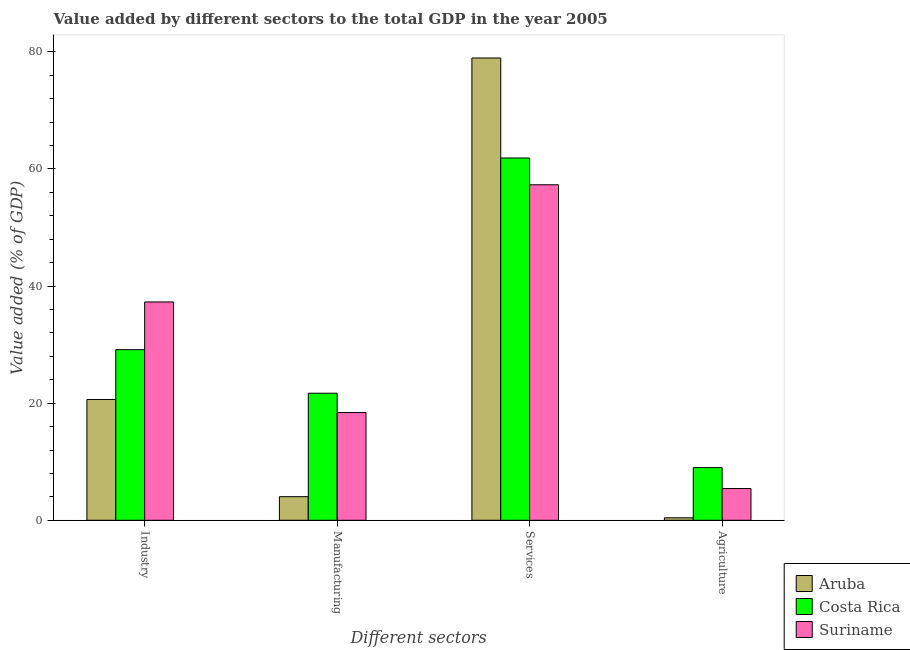How many different coloured bars are there?
Make the answer very short. 3. How many bars are there on the 2nd tick from the right?
Provide a short and direct response. 3. What is the label of the 4th group of bars from the left?
Your answer should be compact. Agriculture. What is the value added by services sector in Costa Rica?
Your response must be concise. 61.87. Across all countries, what is the maximum value added by manufacturing sector?
Make the answer very short. 21.7. Across all countries, what is the minimum value added by services sector?
Provide a succinct answer. 57.3. In which country was the value added by industrial sector minimum?
Make the answer very short. Aruba. What is the total value added by industrial sector in the graph?
Your response must be concise. 87.05. What is the difference between the value added by services sector in Suriname and that in Aruba?
Give a very brief answer. -21.65. What is the difference between the value added by industrial sector in Aruba and the value added by services sector in Costa Rica?
Your response must be concise. -41.24. What is the average value added by services sector per country?
Provide a succinct answer. 66.04. What is the difference between the value added by services sector and value added by agricultural sector in Costa Rica?
Make the answer very short. 52.88. In how many countries, is the value added by industrial sector greater than 8 %?
Your answer should be compact. 3. What is the ratio of the value added by industrial sector in Costa Rica to that in Aruba?
Offer a terse response. 1.41. Is the difference between the value added by agricultural sector in Suriname and Aruba greater than the difference between the value added by industrial sector in Suriname and Aruba?
Keep it short and to the point. No. What is the difference between the highest and the second highest value added by services sector?
Ensure brevity in your answer.  17.08. What is the difference between the highest and the lowest value added by agricultural sector?
Provide a short and direct response. 8.57. Is it the case that in every country, the sum of the value added by agricultural sector and value added by services sector is greater than the sum of value added by manufacturing sector and value added by industrial sector?
Ensure brevity in your answer.  Yes. What does the 2nd bar from the left in Services represents?
Give a very brief answer. Costa Rica. What does the 1st bar from the right in Manufacturing represents?
Your answer should be very brief. Suriname. How many bars are there?
Your answer should be compact. 12. Are all the bars in the graph horizontal?
Ensure brevity in your answer.  No. Are the values on the major ticks of Y-axis written in scientific E-notation?
Make the answer very short. No. Does the graph contain grids?
Make the answer very short. No. How many legend labels are there?
Provide a succinct answer. 3. How are the legend labels stacked?
Your answer should be very brief. Vertical. What is the title of the graph?
Keep it short and to the point. Value added by different sectors to the total GDP in the year 2005. Does "Lower middle income" appear as one of the legend labels in the graph?
Provide a short and direct response. No. What is the label or title of the X-axis?
Provide a succinct answer. Different sectors. What is the label or title of the Y-axis?
Ensure brevity in your answer.  Value added (% of GDP). What is the Value added (% of GDP) in Aruba in Industry?
Your answer should be very brief. 20.63. What is the Value added (% of GDP) of Costa Rica in Industry?
Give a very brief answer. 29.14. What is the Value added (% of GDP) in Suriname in Industry?
Your response must be concise. 37.28. What is the Value added (% of GDP) of Aruba in Manufacturing?
Make the answer very short. 4.03. What is the Value added (% of GDP) of Costa Rica in Manufacturing?
Keep it short and to the point. 21.7. What is the Value added (% of GDP) of Suriname in Manufacturing?
Offer a very short reply. 18.39. What is the Value added (% of GDP) of Aruba in Services?
Offer a terse response. 78.95. What is the Value added (% of GDP) in Costa Rica in Services?
Your answer should be compact. 61.87. What is the Value added (% of GDP) of Suriname in Services?
Your response must be concise. 57.3. What is the Value added (% of GDP) in Aruba in Agriculture?
Offer a terse response. 0.42. What is the Value added (% of GDP) of Costa Rica in Agriculture?
Your response must be concise. 8.99. What is the Value added (% of GDP) of Suriname in Agriculture?
Ensure brevity in your answer.  5.42. Across all Different sectors, what is the maximum Value added (% of GDP) of Aruba?
Ensure brevity in your answer.  78.95. Across all Different sectors, what is the maximum Value added (% of GDP) of Costa Rica?
Keep it short and to the point. 61.87. Across all Different sectors, what is the maximum Value added (% of GDP) of Suriname?
Offer a very short reply. 57.3. Across all Different sectors, what is the minimum Value added (% of GDP) of Aruba?
Ensure brevity in your answer.  0.42. Across all Different sectors, what is the minimum Value added (% of GDP) in Costa Rica?
Ensure brevity in your answer.  8.99. Across all Different sectors, what is the minimum Value added (% of GDP) of Suriname?
Make the answer very short. 5.42. What is the total Value added (% of GDP) in Aruba in the graph?
Offer a very short reply. 104.03. What is the total Value added (% of GDP) of Costa Rica in the graph?
Offer a terse response. 121.7. What is the total Value added (% of GDP) of Suriname in the graph?
Your response must be concise. 118.39. What is the difference between the Value added (% of GDP) of Aruba in Industry and that in Manufacturing?
Keep it short and to the point. 16.6. What is the difference between the Value added (% of GDP) of Costa Rica in Industry and that in Manufacturing?
Your response must be concise. 7.44. What is the difference between the Value added (% of GDP) of Suriname in Industry and that in Manufacturing?
Provide a short and direct response. 18.89. What is the difference between the Value added (% of GDP) in Aruba in Industry and that in Services?
Give a very brief answer. -58.32. What is the difference between the Value added (% of GDP) in Costa Rica in Industry and that in Services?
Your answer should be very brief. -32.74. What is the difference between the Value added (% of GDP) of Suriname in Industry and that in Services?
Provide a succinct answer. -20.01. What is the difference between the Value added (% of GDP) in Aruba in Industry and that in Agriculture?
Ensure brevity in your answer.  20.21. What is the difference between the Value added (% of GDP) in Costa Rica in Industry and that in Agriculture?
Your answer should be compact. 20.14. What is the difference between the Value added (% of GDP) of Suriname in Industry and that in Agriculture?
Keep it short and to the point. 31.86. What is the difference between the Value added (% of GDP) of Aruba in Manufacturing and that in Services?
Provide a short and direct response. -74.92. What is the difference between the Value added (% of GDP) of Costa Rica in Manufacturing and that in Services?
Provide a succinct answer. -40.18. What is the difference between the Value added (% of GDP) in Suriname in Manufacturing and that in Services?
Your answer should be compact. -38.9. What is the difference between the Value added (% of GDP) in Aruba in Manufacturing and that in Agriculture?
Make the answer very short. 3.61. What is the difference between the Value added (% of GDP) of Costa Rica in Manufacturing and that in Agriculture?
Your answer should be very brief. 12.7. What is the difference between the Value added (% of GDP) in Suriname in Manufacturing and that in Agriculture?
Provide a short and direct response. 12.97. What is the difference between the Value added (% of GDP) of Aruba in Services and that in Agriculture?
Provide a short and direct response. 78.53. What is the difference between the Value added (% of GDP) of Costa Rica in Services and that in Agriculture?
Your response must be concise. 52.88. What is the difference between the Value added (% of GDP) in Suriname in Services and that in Agriculture?
Your response must be concise. 51.88. What is the difference between the Value added (% of GDP) of Aruba in Industry and the Value added (% of GDP) of Costa Rica in Manufacturing?
Keep it short and to the point. -1.07. What is the difference between the Value added (% of GDP) of Aruba in Industry and the Value added (% of GDP) of Suriname in Manufacturing?
Offer a terse response. 2.23. What is the difference between the Value added (% of GDP) of Costa Rica in Industry and the Value added (% of GDP) of Suriname in Manufacturing?
Offer a terse response. 10.74. What is the difference between the Value added (% of GDP) of Aruba in Industry and the Value added (% of GDP) of Costa Rica in Services?
Your response must be concise. -41.24. What is the difference between the Value added (% of GDP) in Aruba in Industry and the Value added (% of GDP) in Suriname in Services?
Make the answer very short. -36.67. What is the difference between the Value added (% of GDP) of Costa Rica in Industry and the Value added (% of GDP) of Suriname in Services?
Your answer should be compact. -28.16. What is the difference between the Value added (% of GDP) of Aruba in Industry and the Value added (% of GDP) of Costa Rica in Agriculture?
Your response must be concise. 11.64. What is the difference between the Value added (% of GDP) of Aruba in Industry and the Value added (% of GDP) of Suriname in Agriculture?
Your answer should be very brief. 15.21. What is the difference between the Value added (% of GDP) in Costa Rica in Industry and the Value added (% of GDP) in Suriname in Agriculture?
Ensure brevity in your answer.  23.72. What is the difference between the Value added (% of GDP) in Aruba in Manufacturing and the Value added (% of GDP) in Costa Rica in Services?
Provide a short and direct response. -57.84. What is the difference between the Value added (% of GDP) in Aruba in Manufacturing and the Value added (% of GDP) in Suriname in Services?
Your answer should be compact. -53.27. What is the difference between the Value added (% of GDP) in Costa Rica in Manufacturing and the Value added (% of GDP) in Suriname in Services?
Keep it short and to the point. -35.6. What is the difference between the Value added (% of GDP) in Aruba in Manufacturing and the Value added (% of GDP) in Costa Rica in Agriculture?
Make the answer very short. -4.96. What is the difference between the Value added (% of GDP) of Aruba in Manufacturing and the Value added (% of GDP) of Suriname in Agriculture?
Provide a succinct answer. -1.39. What is the difference between the Value added (% of GDP) in Costa Rica in Manufacturing and the Value added (% of GDP) in Suriname in Agriculture?
Give a very brief answer. 16.28. What is the difference between the Value added (% of GDP) of Aruba in Services and the Value added (% of GDP) of Costa Rica in Agriculture?
Your response must be concise. 69.96. What is the difference between the Value added (% of GDP) of Aruba in Services and the Value added (% of GDP) of Suriname in Agriculture?
Give a very brief answer. 73.53. What is the difference between the Value added (% of GDP) in Costa Rica in Services and the Value added (% of GDP) in Suriname in Agriculture?
Provide a succinct answer. 56.45. What is the average Value added (% of GDP) in Aruba per Different sectors?
Keep it short and to the point. 26.01. What is the average Value added (% of GDP) in Costa Rica per Different sectors?
Make the answer very short. 30.42. What is the average Value added (% of GDP) in Suriname per Different sectors?
Offer a terse response. 29.6. What is the difference between the Value added (% of GDP) of Aruba and Value added (% of GDP) of Costa Rica in Industry?
Ensure brevity in your answer.  -8.51. What is the difference between the Value added (% of GDP) of Aruba and Value added (% of GDP) of Suriname in Industry?
Provide a short and direct response. -16.65. What is the difference between the Value added (% of GDP) in Costa Rica and Value added (% of GDP) in Suriname in Industry?
Provide a short and direct response. -8.15. What is the difference between the Value added (% of GDP) of Aruba and Value added (% of GDP) of Costa Rica in Manufacturing?
Offer a very short reply. -17.66. What is the difference between the Value added (% of GDP) of Aruba and Value added (% of GDP) of Suriname in Manufacturing?
Your answer should be very brief. -14.36. What is the difference between the Value added (% of GDP) in Costa Rica and Value added (% of GDP) in Suriname in Manufacturing?
Ensure brevity in your answer.  3.3. What is the difference between the Value added (% of GDP) of Aruba and Value added (% of GDP) of Costa Rica in Services?
Your response must be concise. 17.08. What is the difference between the Value added (% of GDP) of Aruba and Value added (% of GDP) of Suriname in Services?
Your answer should be very brief. 21.65. What is the difference between the Value added (% of GDP) of Costa Rica and Value added (% of GDP) of Suriname in Services?
Make the answer very short. 4.57. What is the difference between the Value added (% of GDP) of Aruba and Value added (% of GDP) of Costa Rica in Agriculture?
Keep it short and to the point. -8.57. What is the difference between the Value added (% of GDP) in Aruba and Value added (% of GDP) in Suriname in Agriculture?
Offer a terse response. -5. What is the difference between the Value added (% of GDP) of Costa Rica and Value added (% of GDP) of Suriname in Agriculture?
Offer a very short reply. 3.57. What is the ratio of the Value added (% of GDP) of Aruba in Industry to that in Manufacturing?
Provide a short and direct response. 5.12. What is the ratio of the Value added (% of GDP) in Costa Rica in Industry to that in Manufacturing?
Your response must be concise. 1.34. What is the ratio of the Value added (% of GDP) of Suriname in Industry to that in Manufacturing?
Make the answer very short. 2.03. What is the ratio of the Value added (% of GDP) in Aruba in Industry to that in Services?
Provide a succinct answer. 0.26. What is the ratio of the Value added (% of GDP) of Costa Rica in Industry to that in Services?
Give a very brief answer. 0.47. What is the ratio of the Value added (% of GDP) in Suriname in Industry to that in Services?
Ensure brevity in your answer.  0.65. What is the ratio of the Value added (% of GDP) of Aruba in Industry to that in Agriculture?
Offer a terse response. 48.96. What is the ratio of the Value added (% of GDP) of Costa Rica in Industry to that in Agriculture?
Provide a succinct answer. 3.24. What is the ratio of the Value added (% of GDP) of Suriname in Industry to that in Agriculture?
Offer a terse response. 6.88. What is the ratio of the Value added (% of GDP) of Aruba in Manufacturing to that in Services?
Offer a very short reply. 0.05. What is the ratio of the Value added (% of GDP) in Costa Rica in Manufacturing to that in Services?
Keep it short and to the point. 0.35. What is the ratio of the Value added (% of GDP) in Suriname in Manufacturing to that in Services?
Your response must be concise. 0.32. What is the ratio of the Value added (% of GDP) in Aruba in Manufacturing to that in Agriculture?
Ensure brevity in your answer.  9.57. What is the ratio of the Value added (% of GDP) of Costa Rica in Manufacturing to that in Agriculture?
Your response must be concise. 2.41. What is the ratio of the Value added (% of GDP) of Suriname in Manufacturing to that in Agriculture?
Offer a very short reply. 3.39. What is the ratio of the Value added (% of GDP) in Aruba in Services to that in Agriculture?
Your answer should be very brief. 187.39. What is the ratio of the Value added (% of GDP) in Costa Rica in Services to that in Agriculture?
Provide a short and direct response. 6.88. What is the ratio of the Value added (% of GDP) of Suriname in Services to that in Agriculture?
Make the answer very short. 10.57. What is the difference between the highest and the second highest Value added (% of GDP) in Aruba?
Ensure brevity in your answer.  58.32. What is the difference between the highest and the second highest Value added (% of GDP) in Costa Rica?
Your answer should be compact. 32.74. What is the difference between the highest and the second highest Value added (% of GDP) of Suriname?
Your answer should be compact. 20.01. What is the difference between the highest and the lowest Value added (% of GDP) of Aruba?
Offer a very short reply. 78.53. What is the difference between the highest and the lowest Value added (% of GDP) of Costa Rica?
Provide a succinct answer. 52.88. What is the difference between the highest and the lowest Value added (% of GDP) in Suriname?
Your response must be concise. 51.88. 